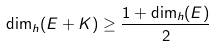Convert formula to latex. <formula><loc_0><loc_0><loc_500><loc_500>\dim _ { h } ( E + K ) \geq \frac { 1 + \dim _ { h } ( E ) } { 2 }</formula> 